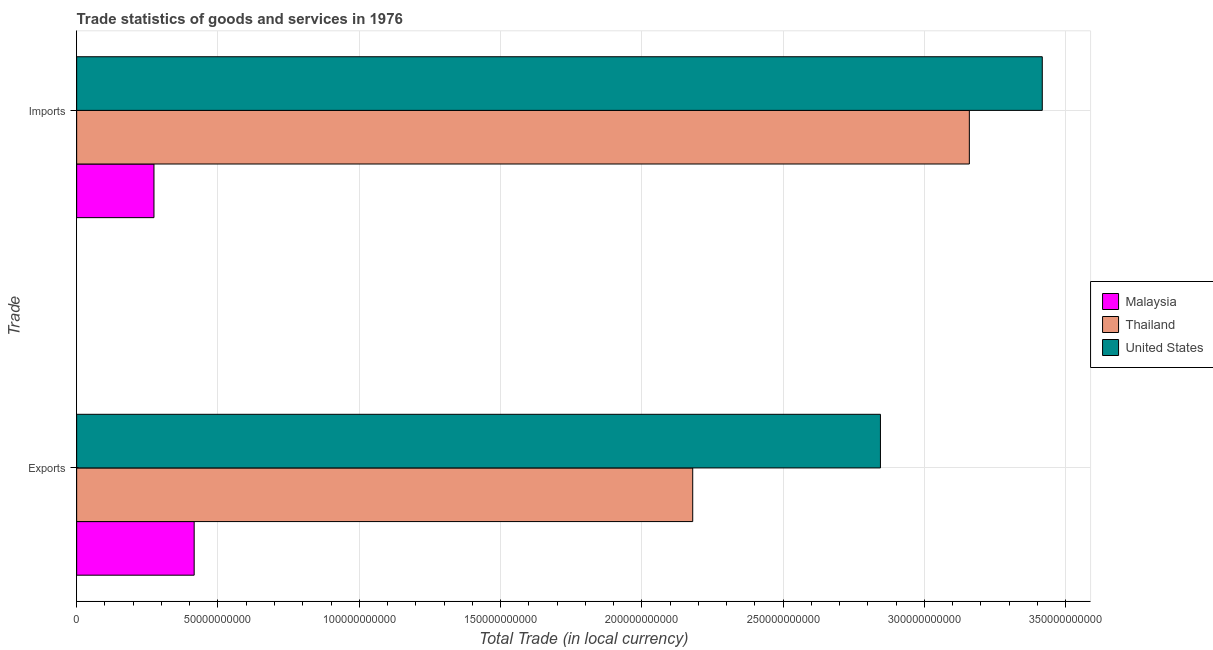How many different coloured bars are there?
Provide a short and direct response. 3. Are the number of bars per tick equal to the number of legend labels?
Provide a succinct answer. Yes. What is the label of the 2nd group of bars from the top?
Keep it short and to the point. Exports. What is the imports of goods and services in Thailand?
Give a very brief answer. 3.16e+11. Across all countries, what is the maximum imports of goods and services?
Provide a succinct answer. 3.42e+11. Across all countries, what is the minimum export of goods and services?
Ensure brevity in your answer.  4.16e+1. In which country was the imports of goods and services maximum?
Provide a succinct answer. United States. In which country was the imports of goods and services minimum?
Offer a terse response. Malaysia. What is the total export of goods and services in the graph?
Make the answer very short. 5.44e+11. What is the difference between the imports of goods and services in Malaysia and that in United States?
Offer a very short reply. -3.14e+11. What is the difference between the export of goods and services in United States and the imports of goods and services in Thailand?
Your response must be concise. -3.15e+1. What is the average imports of goods and services per country?
Make the answer very short. 2.28e+11. What is the difference between the imports of goods and services and export of goods and services in Thailand?
Your answer should be compact. 9.79e+1. In how many countries, is the imports of goods and services greater than 150000000000 LCU?
Your answer should be very brief. 2. What is the ratio of the export of goods and services in United States to that in Thailand?
Make the answer very short. 1.3. What does the 1st bar from the top in Imports represents?
Your answer should be compact. United States. What does the 2nd bar from the bottom in Exports represents?
Ensure brevity in your answer.  Thailand. How many countries are there in the graph?
Keep it short and to the point. 3. What is the difference between two consecutive major ticks on the X-axis?
Your answer should be very brief. 5.00e+1. Where does the legend appear in the graph?
Offer a very short reply. Center right. What is the title of the graph?
Your response must be concise. Trade statistics of goods and services in 1976. Does "South Asia" appear as one of the legend labels in the graph?
Give a very brief answer. No. What is the label or title of the X-axis?
Make the answer very short. Total Trade (in local currency). What is the label or title of the Y-axis?
Give a very brief answer. Trade. What is the Total Trade (in local currency) of Malaysia in Exports?
Your answer should be compact. 4.16e+1. What is the Total Trade (in local currency) of Thailand in Exports?
Provide a succinct answer. 2.18e+11. What is the Total Trade (in local currency) in United States in Exports?
Give a very brief answer. 2.84e+11. What is the Total Trade (in local currency) of Malaysia in Imports?
Make the answer very short. 2.74e+1. What is the Total Trade (in local currency) in Thailand in Imports?
Provide a short and direct response. 3.16e+11. What is the Total Trade (in local currency) of United States in Imports?
Offer a very short reply. 3.42e+11. Across all Trade, what is the maximum Total Trade (in local currency) of Malaysia?
Ensure brevity in your answer.  4.16e+1. Across all Trade, what is the maximum Total Trade (in local currency) of Thailand?
Your answer should be very brief. 3.16e+11. Across all Trade, what is the maximum Total Trade (in local currency) in United States?
Provide a succinct answer. 3.42e+11. Across all Trade, what is the minimum Total Trade (in local currency) in Malaysia?
Make the answer very short. 2.74e+1. Across all Trade, what is the minimum Total Trade (in local currency) in Thailand?
Offer a very short reply. 2.18e+11. Across all Trade, what is the minimum Total Trade (in local currency) of United States?
Offer a terse response. 2.84e+11. What is the total Total Trade (in local currency) of Malaysia in the graph?
Make the answer very short. 6.89e+1. What is the total Total Trade (in local currency) in Thailand in the graph?
Provide a succinct answer. 5.34e+11. What is the total Total Trade (in local currency) in United States in the graph?
Keep it short and to the point. 6.26e+11. What is the difference between the Total Trade (in local currency) of Malaysia in Exports and that in Imports?
Your answer should be compact. 1.42e+1. What is the difference between the Total Trade (in local currency) of Thailand in Exports and that in Imports?
Provide a short and direct response. -9.79e+1. What is the difference between the Total Trade (in local currency) in United States in Exports and that in Imports?
Offer a terse response. -5.73e+1. What is the difference between the Total Trade (in local currency) of Malaysia in Exports and the Total Trade (in local currency) of Thailand in Imports?
Offer a terse response. -2.74e+11. What is the difference between the Total Trade (in local currency) in Malaysia in Exports and the Total Trade (in local currency) in United States in Imports?
Your answer should be very brief. -3.00e+11. What is the difference between the Total Trade (in local currency) of Thailand in Exports and the Total Trade (in local currency) of United States in Imports?
Provide a short and direct response. -1.24e+11. What is the average Total Trade (in local currency) of Malaysia per Trade?
Your answer should be compact. 3.45e+1. What is the average Total Trade (in local currency) of Thailand per Trade?
Make the answer very short. 2.67e+11. What is the average Total Trade (in local currency) of United States per Trade?
Keep it short and to the point. 3.13e+11. What is the difference between the Total Trade (in local currency) of Malaysia and Total Trade (in local currency) of Thailand in Exports?
Your response must be concise. -1.76e+11. What is the difference between the Total Trade (in local currency) in Malaysia and Total Trade (in local currency) in United States in Exports?
Ensure brevity in your answer.  -2.43e+11. What is the difference between the Total Trade (in local currency) of Thailand and Total Trade (in local currency) of United States in Exports?
Keep it short and to the point. -6.64e+1. What is the difference between the Total Trade (in local currency) in Malaysia and Total Trade (in local currency) in Thailand in Imports?
Keep it short and to the point. -2.89e+11. What is the difference between the Total Trade (in local currency) of Malaysia and Total Trade (in local currency) of United States in Imports?
Provide a short and direct response. -3.14e+11. What is the difference between the Total Trade (in local currency) of Thailand and Total Trade (in local currency) of United States in Imports?
Make the answer very short. -2.58e+1. What is the ratio of the Total Trade (in local currency) in Malaysia in Exports to that in Imports?
Make the answer very short. 1.52. What is the ratio of the Total Trade (in local currency) of Thailand in Exports to that in Imports?
Provide a short and direct response. 0.69. What is the ratio of the Total Trade (in local currency) of United States in Exports to that in Imports?
Ensure brevity in your answer.  0.83. What is the difference between the highest and the second highest Total Trade (in local currency) of Malaysia?
Keep it short and to the point. 1.42e+1. What is the difference between the highest and the second highest Total Trade (in local currency) in Thailand?
Give a very brief answer. 9.79e+1. What is the difference between the highest and the second highest Total Trade (in local currency) in United States?
Your response must be concise. 5.73e+1. What is the difference between the highest and the lowest Total Trade (in local currency) in Malaysia?
Keep it short and to the point. 1.42e+1. What is the difference between the highest and the lowest Total Trade (in local currency) in Thailand?
Give a very brief answer. 9.79e+1. What is the difference between the highest and the lowest Total Trade (in local currency) of United States?
Make the answer very short. 5.73e+1. 